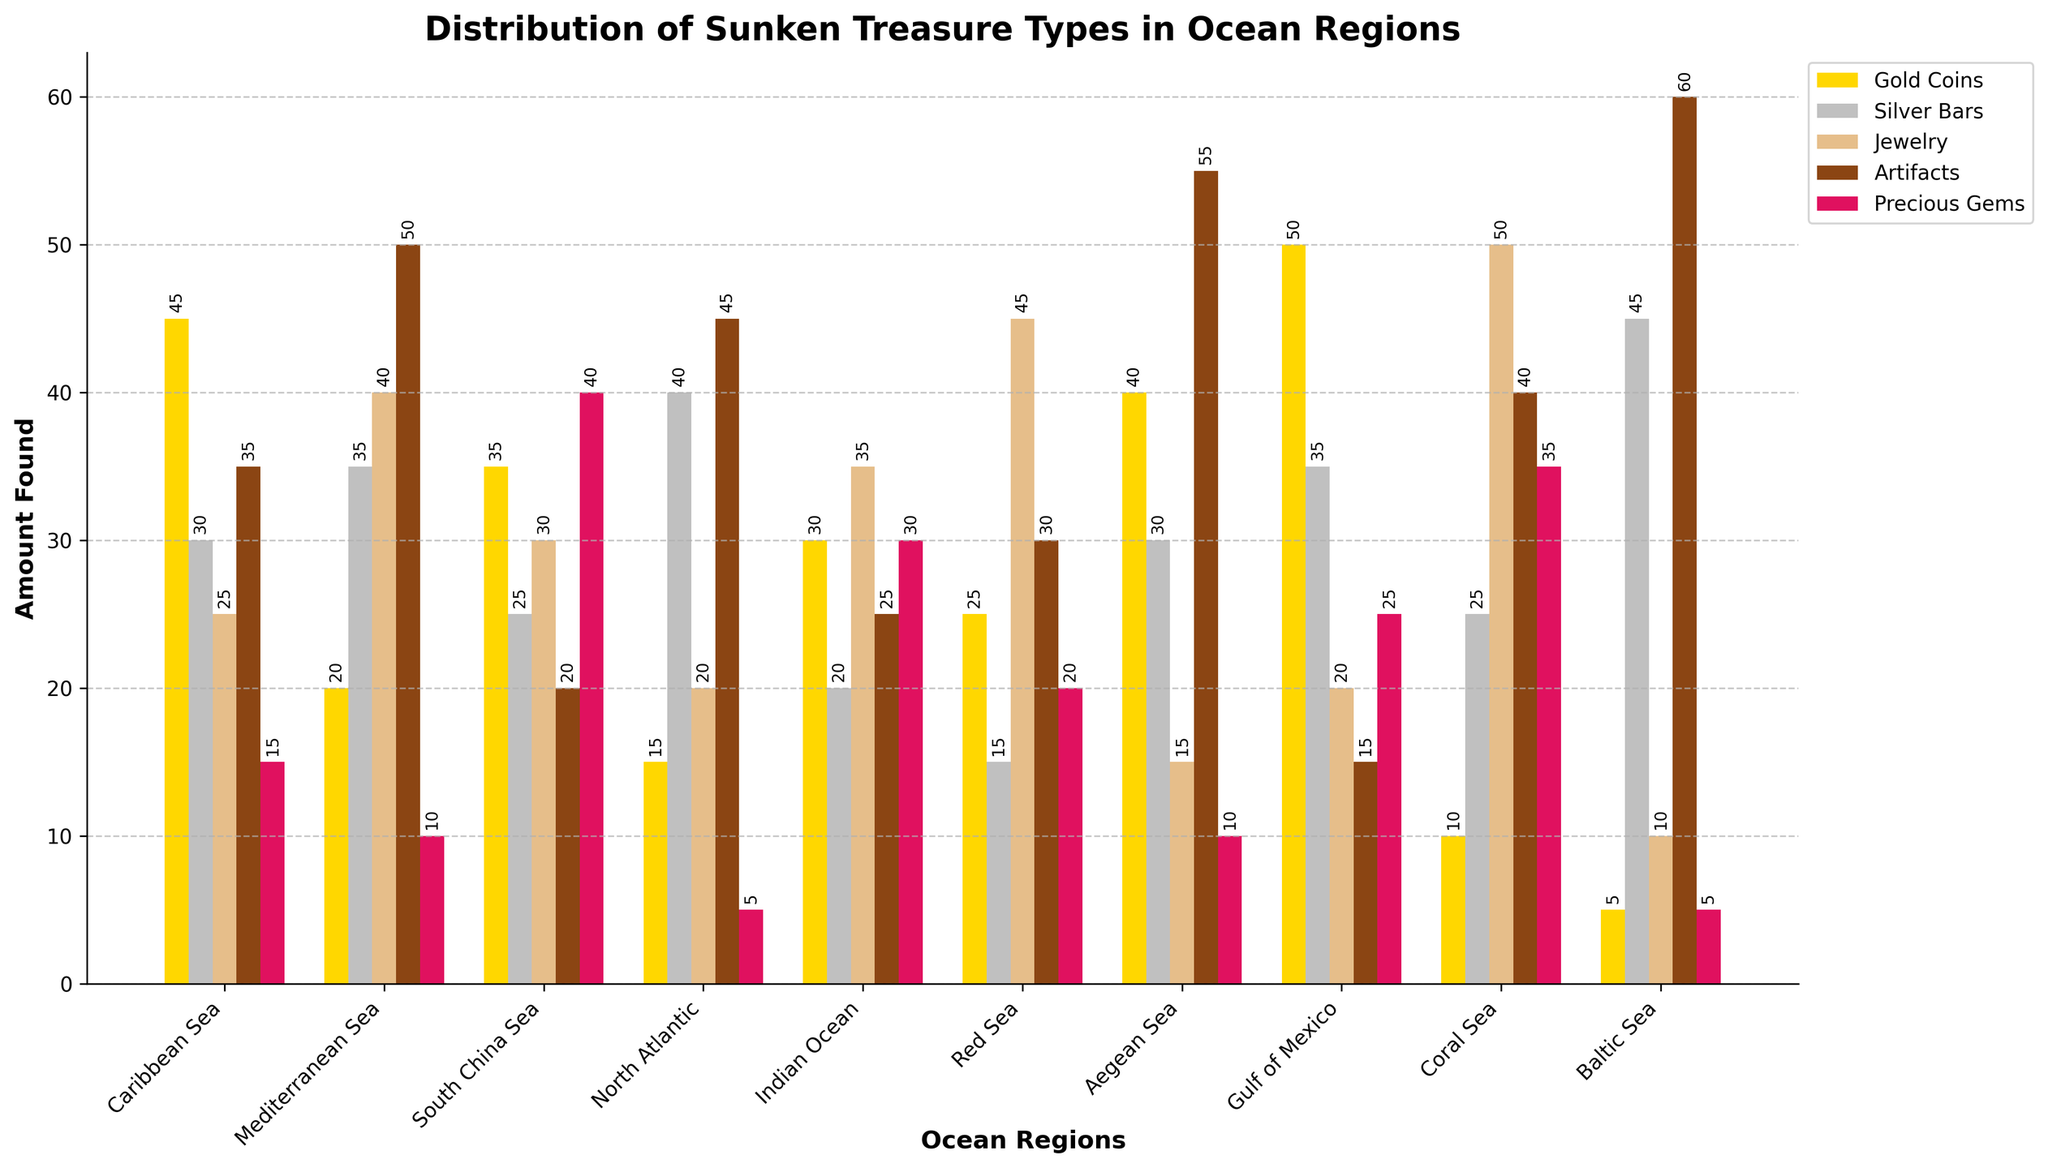What is the ocean region with the highest amount of gold coins? First, identify the heights of the gold coin bars for each ocean region. Compare the heights visually or by reading the values above the bars. The tallest bar represents the region with the highest amount.
Answer: Gulf of Mexico Which ocean region has the least amount of precious gems? Look at the heights of the bars representing precious gems (often identified by a pinkish color). Find the shortest bar among these.
Answer: North Atlantic and Baltic Sea What is the total amount of artifacts found across all ocean regions? Sum the amounts of artifacts found in each ocean region: (35 + 50 + 20 + 45 + 25 + 30 + 55 + 15 + 40 + 60).
Answer: 375 Compare the amount of silver bars found in the Caribbean Sea and the North Atlantic. Which region has more, and by how much? Read the values for silver bars in both regions: Caribbean Sea (30) and North Atlantic (40). Subtract the smaller value from the larger one to find the difference.
Answer: North Atlantic, by 10 Which ocean region has a higher combined amount of jewelry and artifacts, Mediterranean Sea or Coral Sea? Calculate the combined amount for both regions. Mediterranean Sea: Jewelry (40) + Artifacts (50) = 90; Coral Sea: Jewelry (50) + Artifacts (40) = 90.
Answer: Both have 90 What is the average amount of silver bars found across all regions? Calculate the total amount of silver bars (sum of all values in the Silver Bars column) and divide by the number of regions (10). (30 + 35 + 25 + 40 + 20 + 15 + 30 + 35 + 25 + 45) / 10 = 30.
Answer: 30 Which treasure type has the largest range of values across all ocean regions? For each treasure type, calculate the range by subtracting the smallest value from the largest value. Compare these ranges to find the largest: Gold Coins (50 - 5 = 45), Silver Bars (45 - 15 = 30), Jewelry (50 - 10 = 40), Artifacts (60 - 15 = 45), Precious Gems (40 - 5 = 35).
Answer: Gold Coins and Artifacts What is the total number of treasures found in the Aegean Sea? Sum the amounts of each treasure type found in the Aegean Sea: (40 + 30 + 15 + 55 + 10).
Answer: 150 In the Red Sea, which treasure type is found more frequently, Jewelry or Precious Gems? Compare the heights of the bars for Jewelry (blue) and Precious Gems (pink) in the Red Sea. Jewelry has 45, and Precious Gems have 20.
Answer: Jewelry Among all the ocean regions, which one has the lowest total amount of treasures found? Calculate the total amount of treasures for each region by summing the respective values. Identify the region with the smallest sum. The sums are: Caribbean Sea (150), Mediterranean Sea (155), South China Sea (150), North Atlantic (125), Indian Ocean (140), Red Sea (135), Aegean Sea (150), Gulf of Mexico (145), Coral Sea (160), Baltic Sea (125).
Answer: North Atlantic and Baltic Sea 